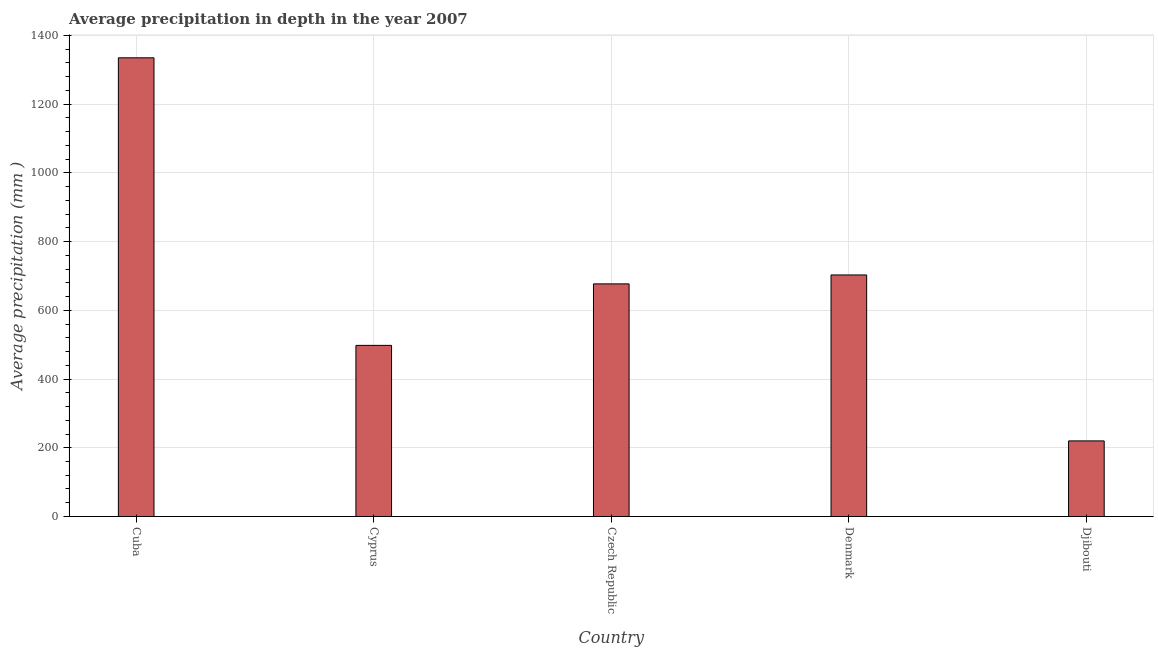Does the graph contain grids?
Give a very brief answer. Yes. What is the title of the graph?
Your response must be concise. Average precipitation in depth in the year 2007. What is the label or title of the Y-axis?
Your answer should be very brief. Average precipitation (mm ). What is the average precipitation in depth in Denmark?
Offer a very short reply. 703. Across all countries, what is the maximum average precipitation in depth?
Keep it short and to the point. 1335. Across all countries, what is the minimum average precipitation in depth?
Provide a short and direct response. 220. In which country was the average precipitation in depth maximum?
Provide a short and direct response. Cuba. In which country was the average precipitation in depth minimum?
Your response must be concise. Djibouti. What is the sum of the average precipitation in depth?
Give a very brief answer. 3433. What is the difference between the average precipitation in depth in Czech Republic and Denmark?
Offer a very short reply. -26. What is the average average precipitation in depth per country?
Make the answer very short. 686. What is the median average precipitation in depth?
Offer a terse response. 677. What is the ratio of the average precipitation in depth in Cuba to that in Czech Republic?
Provide a short and direct response. 1.97. Is the average precipitation in depth in Cuba less than that in Denmark?
Offer a terse response. No. Is the difference between the average precipitation in depth in Denmark and Djibouti greater than the difference between any two countries?
Provide a short and direct response. No. What is the difference between the highest and the second highest average precipitation in depth?
Your answer should be very brief. 632. What is the difference between the highest and the lowest average precipitation in depth?
Make the answer very short. 1115. How many bars are there?
Provide a succinct answer. 5. What is the difference between two consecutive major ticks on the Y-axis?
Keep it short and to the point. 200. What is the Average precipitation (mm ) in Cuba?
Offer a terse response. 1335. What is the Average precipitation (mm ) of Cyprus?
Keep it short and to the point. 498. What is the Average precipitation (mm ) of Czech Republic?
Offer a terse response. 677. What is the Average precipitation (mm ) of Denmark?
Make the answer very short. 703. What is the Average precipitation (mm ) in Djibouti?
Your answer should be very brief. 220. What is the difference between the Average precipitation (mm ) in Cuba and Cyprus?
Your answer should be compact. 837. What is the difference between the Average precipitation (mm ) in Cuba and Czech Republic?
Offer a very short reply. 658. What is the difference between the Average precipitation (mm ) in Cuba and Denmark?
Provide a short and direct response. 632. What is the difference between the Average precipitation (mm ) in Cuba and Djibouti?
Provide a succinct answer. 1115. What is the difference between the Average precipitation (mm ) in Cyprus and Czech Republic?
Offer a very short reply. -179. What is the difference between the Average precipitation (mm ) in Cyprus and Denmark?
Keep it short and to the point. -205. What is the difference between the Average precipitation (mm ) in Cyprus and Djibouti?
Give a very brief answer. 278. What is the difference between the Average precipitation (mm ) in Czech Republic and Denmark?
Ensure brevity in your answer.  -26. What is the difference between the Average precipitation (mm ) in Czech Republic and Djibouti?
Make the answer very short. 457. What is the difference between the Average precipitation (mm ) in Denmark and Djibouti?
Offer a terse response. 483. What is the ratio of the Average precipitation (mm ) in Cuba to that in Cyprus?
Your answer should be compact. 2.68. What is the ratio of the Average precipitation (mm ) in Cuba to that in Czech Republic?
Ensure brevity in your answer.  1.97. What is the ratio of the Average precipitation (mm ) in Cuba to that in Denmark?
Give a very brief answer. 1.9. What is the ratio of the Average precipitation (mm ) in Cuba to that in Djibouti?
Your response must be concise. 6.07. What is the ratio of the Average precipitation (mm ) in Cyprus to that in Czech Republic?
Ensure brevity in your answer.  0.74. What is the ratio of the Average precipitation (mm ) in Cyprus to that in Denmark?
Offer a very short reply. 0.71. What is the ratio of the Average precipitation (mm ) in Cyprus to that in Djibouti?
Your answer should be compact. 2.26. What is the ratio of the Average precipitation (mm ) in Czech Republic to that in Djibouti?
Make the answer very short. 3.08. What is the ratio of the Average precipitation (mm ) in Denmark to that in Djibouti?
Provide a succinct answer. 3.19. 